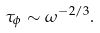<formula> <loc_0><loc_0><loc_500><loc_500>\tau _ { \phi } \sim \omega ^ { - 2 / 3 } .</formula> 